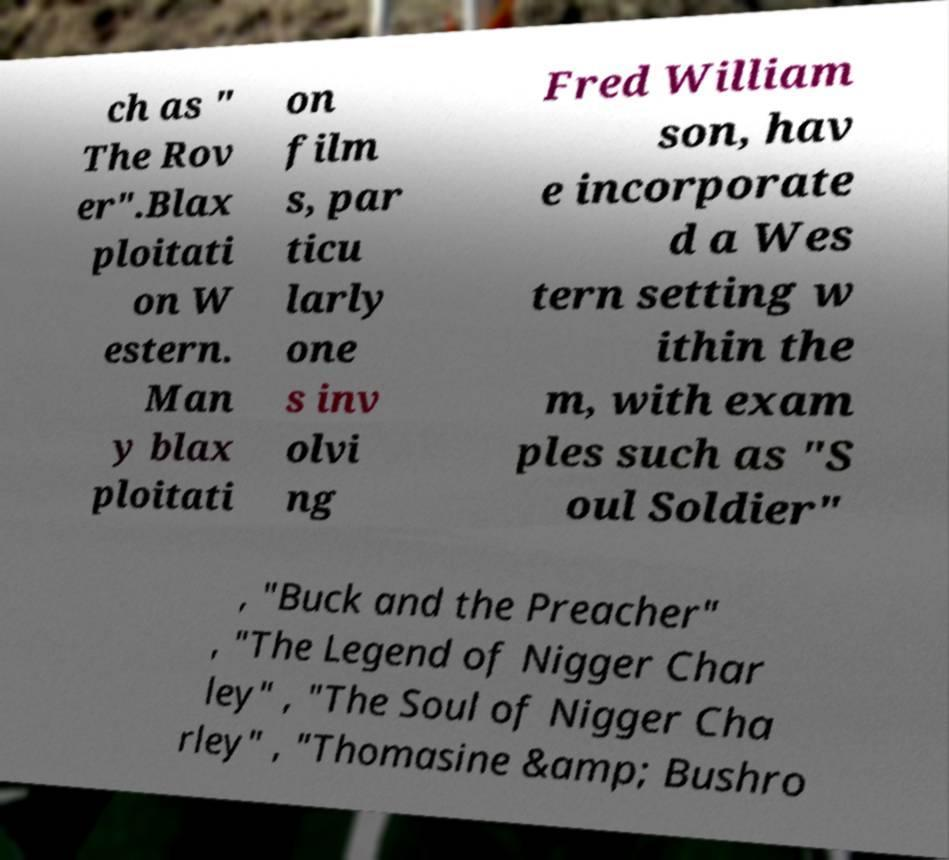Could you assist in decoding the text presented in this image and type it out clearly? ch as " The Rov er".Blax ploitati on W estern. Man y blax ploitati on film s, par ticu larly one s inv olvi ng Fred William son, hav e incorporate d a Wes tern setting w ithin the m, with exam ples such as "S oul Soldier" , "Buck and the Preacher" , "The Legend of Nigger Char ley" , "The Soul of Nigger Cha rley" , "Thomasine &amp; Bushro 